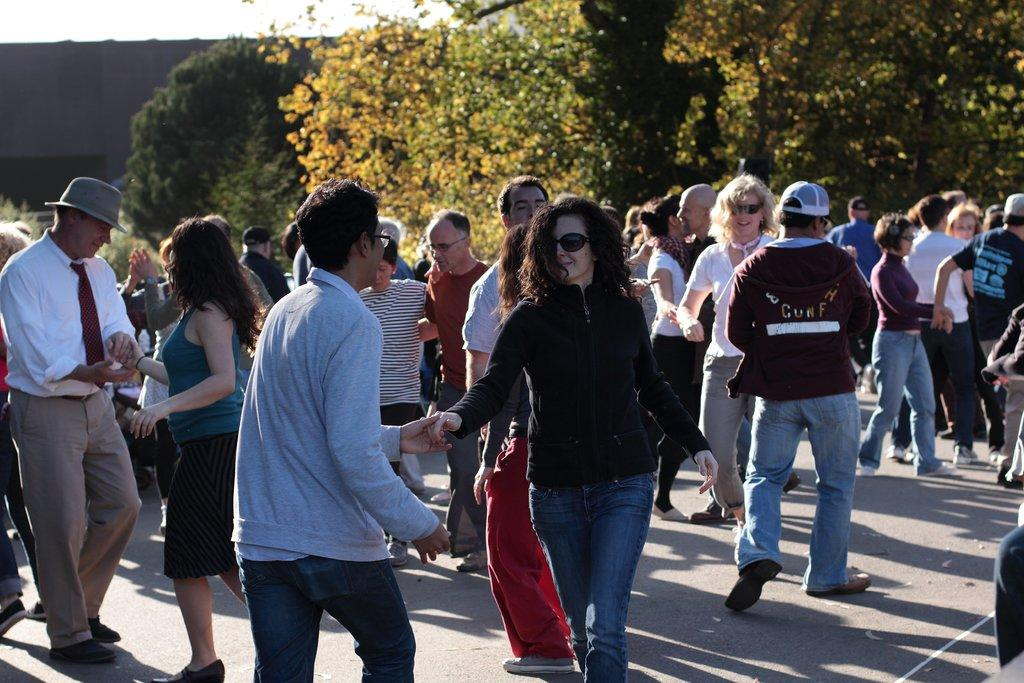Who are the people in the image? There is a man and a woman in the image. What are the man and woman doing in the image? The man and woman are standing and holding hands, and they appear to be dancing. Where are the man and woman located in the image? They are on a path in the image. What can be seen in the background of the image? There are trees and a wall in the background of the image. What type of rock is the man holding in the image? There is no rock present in the image; the man and woman are holding hands while dancing. How many pigs can be seen in the image? There are no pigs present in the image; the subjects are a man and a woman. 